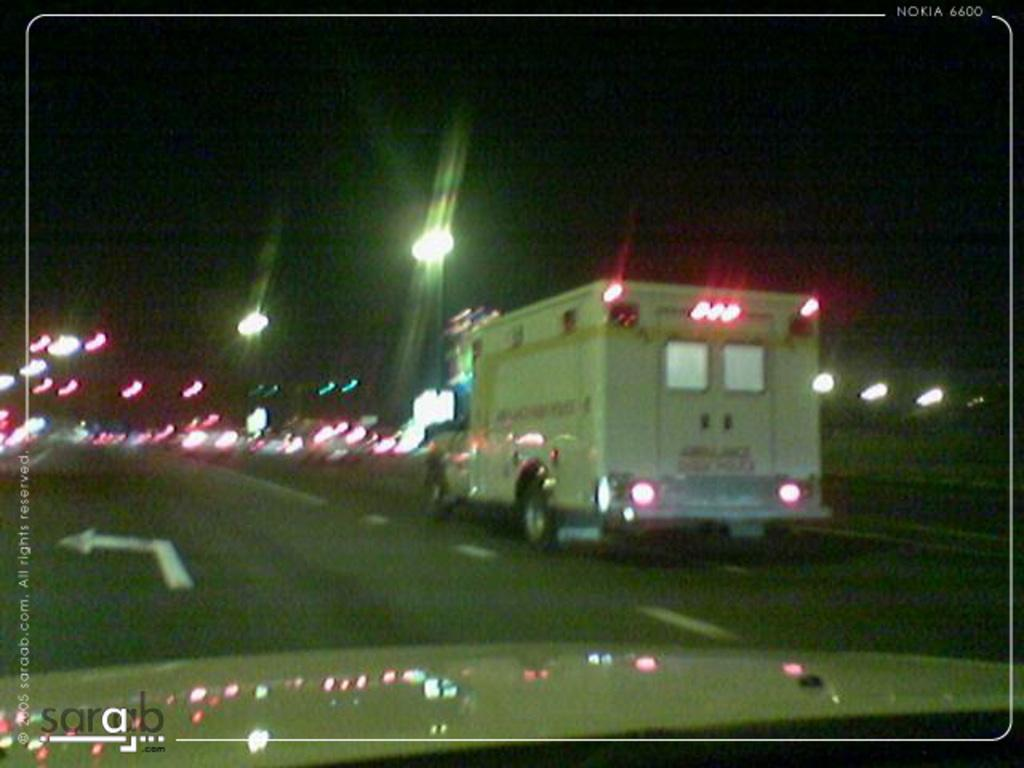What can be seen moving on the road in the image? There are vehicles on the road in the image. What type of markings are present on the road? There are white color lines on the road. What information might be conveyed by the signs on the road? The signs on the road might provide information about speed limits, directions, or other traffic-related instructions. What type of illumination is visible in the image? There are lights visible in the image. How would you describe the overall lighting condition in the image? The background of the image is dark. What type of earth can be seen growing near the road in the image? There is no earth or plant life growing near the road in the image. What type of root system can be seen supporting the vehicles on the road in the image? There is no root system present in the image; the vehicles are supported by the road surface. 